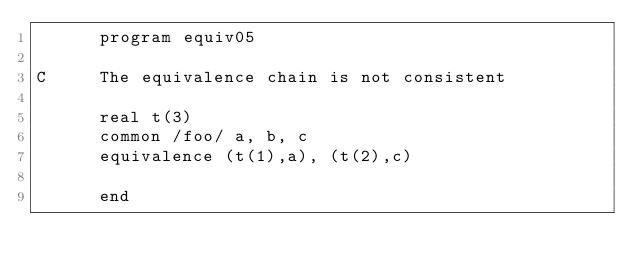<code> <loc_0><loc_0><loc_500><loc_500><_FORTRAN_>      program equiv05

C     The equivalence chain is not consistent

      real t(3)
      common /foo/ a, b, c
      equivalence (t(1),a), (t(2),c)

      end
</code> 